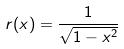<formula> <loc_0><loc_0><loc_500><loc_500>r ( x ) = \frac { 1 } { \sqrt { 1 - x ^ { 2 } } }</formula> 